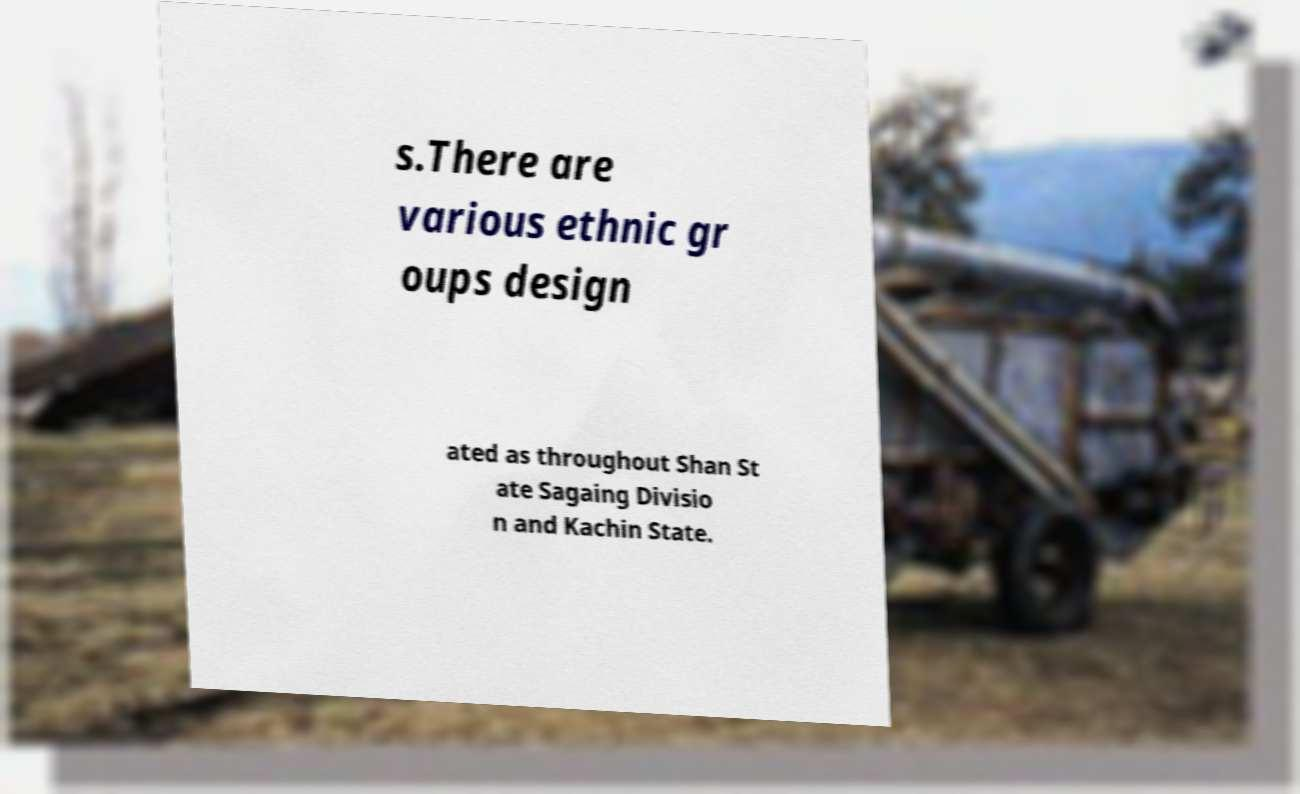What messages or text are displayed in this image? I need them in a readable, typed format. s.There are various ethnic gr oups design ated as throughout Shan St ate Sagaing Divisio n and Kachin State. 